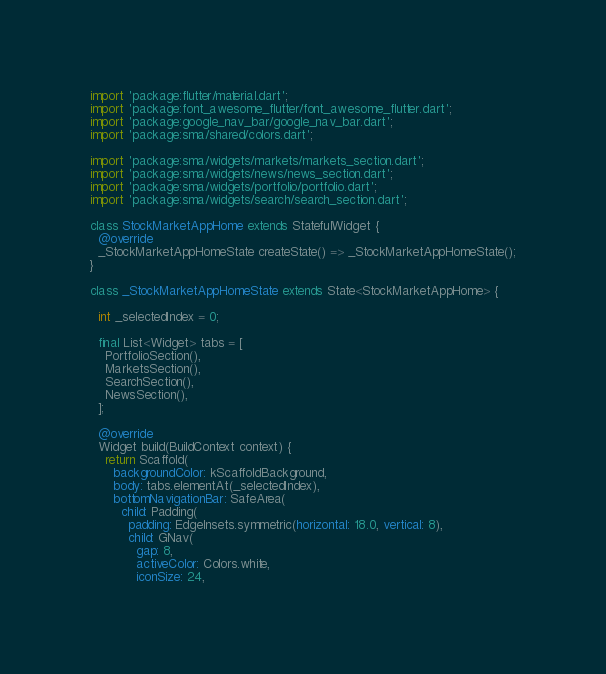<code> <loc_0><loc_0><loc_500><loc_500><_Dart_>import 'package:flutter/material.dart';
import 'package:font_awesome_flutter/font_awesome_flutter.dart';
import 'package:google_nav_bar/google_nav_bar.dart';
import 'package:sma/shared/colors.dart';

import 'package:sma/widgets/markets/markets_section.dart';
import 'package:sma/widgets/news/news_section.dart';
import 'package:sma/widgets/portfolio/portfolio.dart';
import 'package:sma/widgets/search/search_section.dart';

class StockMarketAppHome extends StatefulWidget {
  @override
  _StockMarketAppHomeState createState() => _StockMarketAppHomeState();
}

class _StockMarketAppHomeState extends State<StockMarketAppHome> {

  int _selectedIndex = 0;

  final List<Widget> tabs = [
    PortfolioSection(),
    MarketsSection(),
    SearchSection(),
    NewsSection(),
  ];

  @override
  Widget build(BuildContext context) {
    return Scaffold(
      backgroundColor: kScaffoldBackground,
      body: tabs.elementAt(_selectedIndex),
      bottomNavigationBar: SafeArea(
        child: Padding(
          padding: EdgeInsets.symmetric(horizontal: 18.0, vertical: 8),
          child: GNav(
            gap: 8,
            activeColor: Colors.white,
            iconSize: 24,</code> 